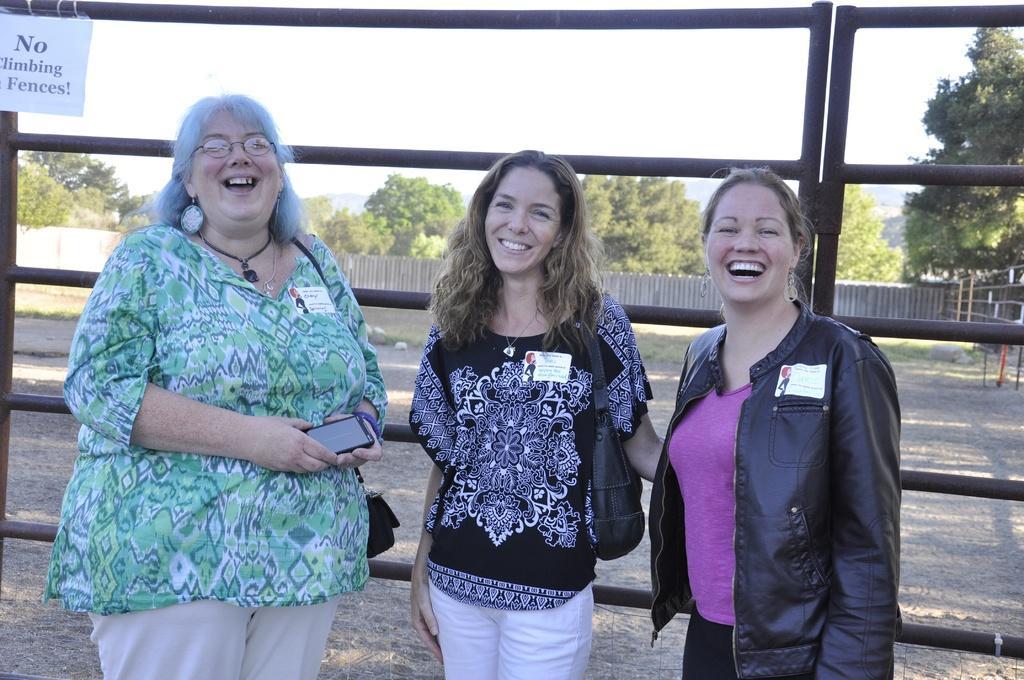Could you give a brief overview of what you see in this image? In this image we can see few people standing and smiling and behind there is a fence and we can see some trees in the background and at the top we can see the sky. 